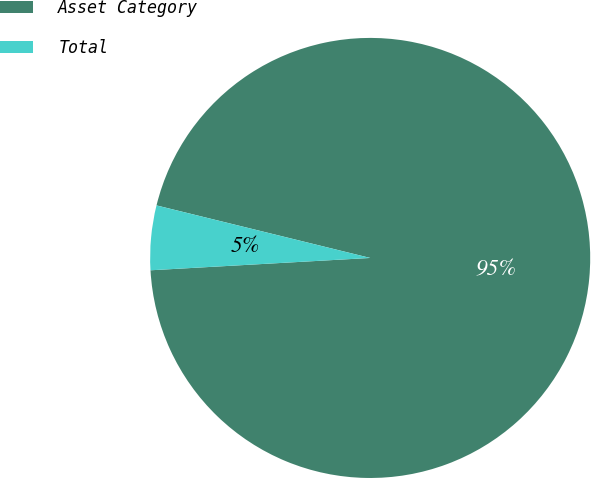Convert chart. <chart><loc_0><loc_0><loc_500><loc_500><pie_chart><fcel>Asset Category<fcel>Total<nl><fcel>95.27%<fcel>4.73%<nl></chart> 